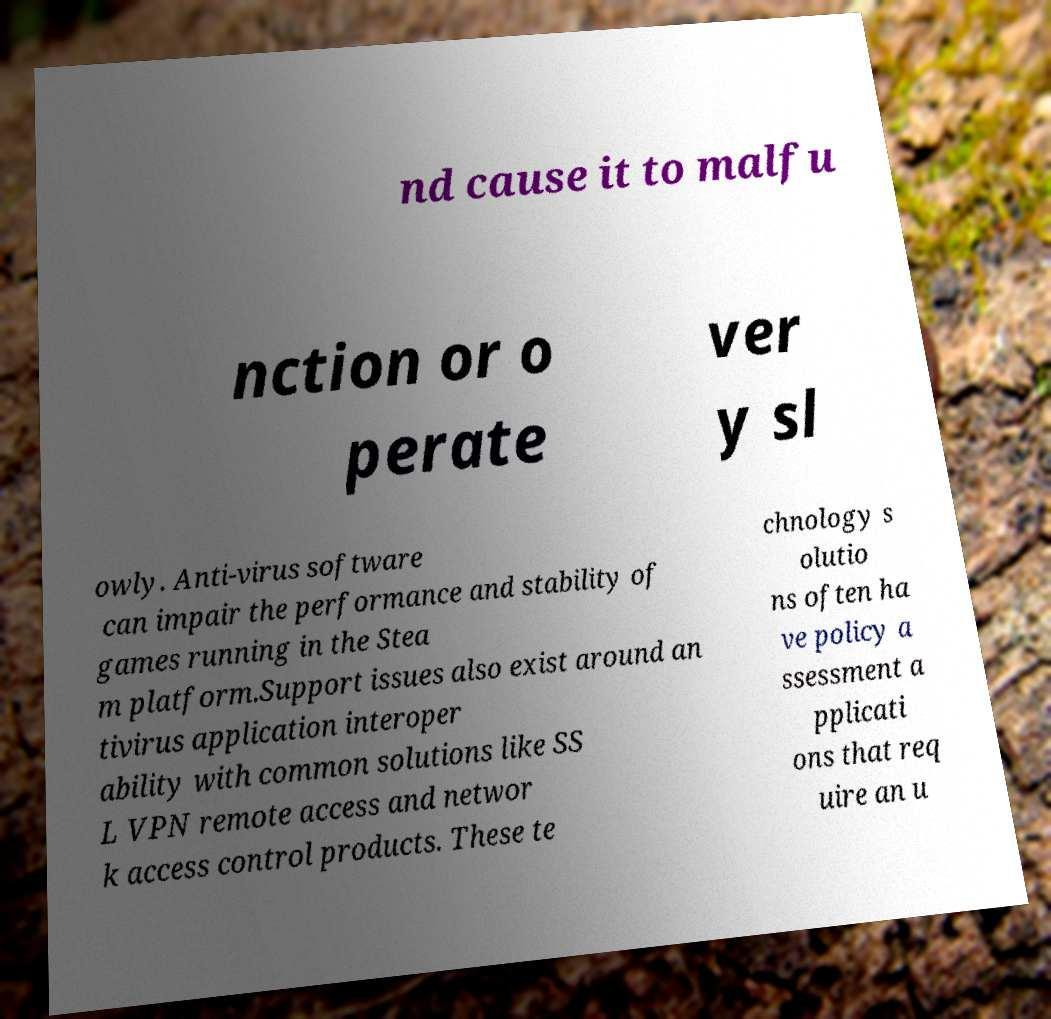There's text embedded in this image that I need extracted. Can you transcribe it verbatim? nd cause it to malfu nction or o perate ver y sl owly. Anti-virus software can impair the performance and stability of games running in the Stea m platform.Support issues also exist around an tivirus application interoper ability with common solutions like SS L VPN remote access and networ k access control products. These te chnology s olutio ns often ha ve policy a ssessment a pplicati ons that req uire an u 